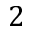<formula> <loc_0><loc_0><loc_500><loc_500>2</formula> 